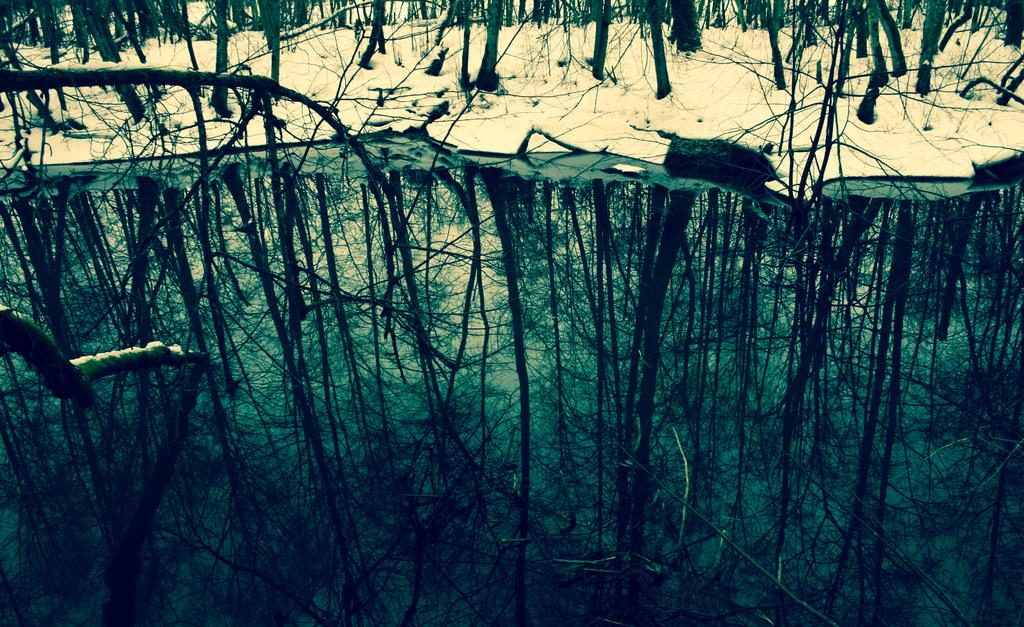What is present in the image that is not solid? There is water in the image. What can be seen reflected on the water's surface? There is a reflection of trees on the water. What type of weather condition is depicted in the image? There is snow visible in the image, indicating a cold or wintry condition. What type of vegetation can be seen in the background of the image? There are trees in the background of the image. What type of bun is being used to hold the snow in the image? There is no bun present in the image; the snow is depicted on the ground or other surfaces. What force is acting on the trees to create the reflection on the water? The reflection on the water is a result of the light's interaction with the water's surface, not a force acting on the trees. 